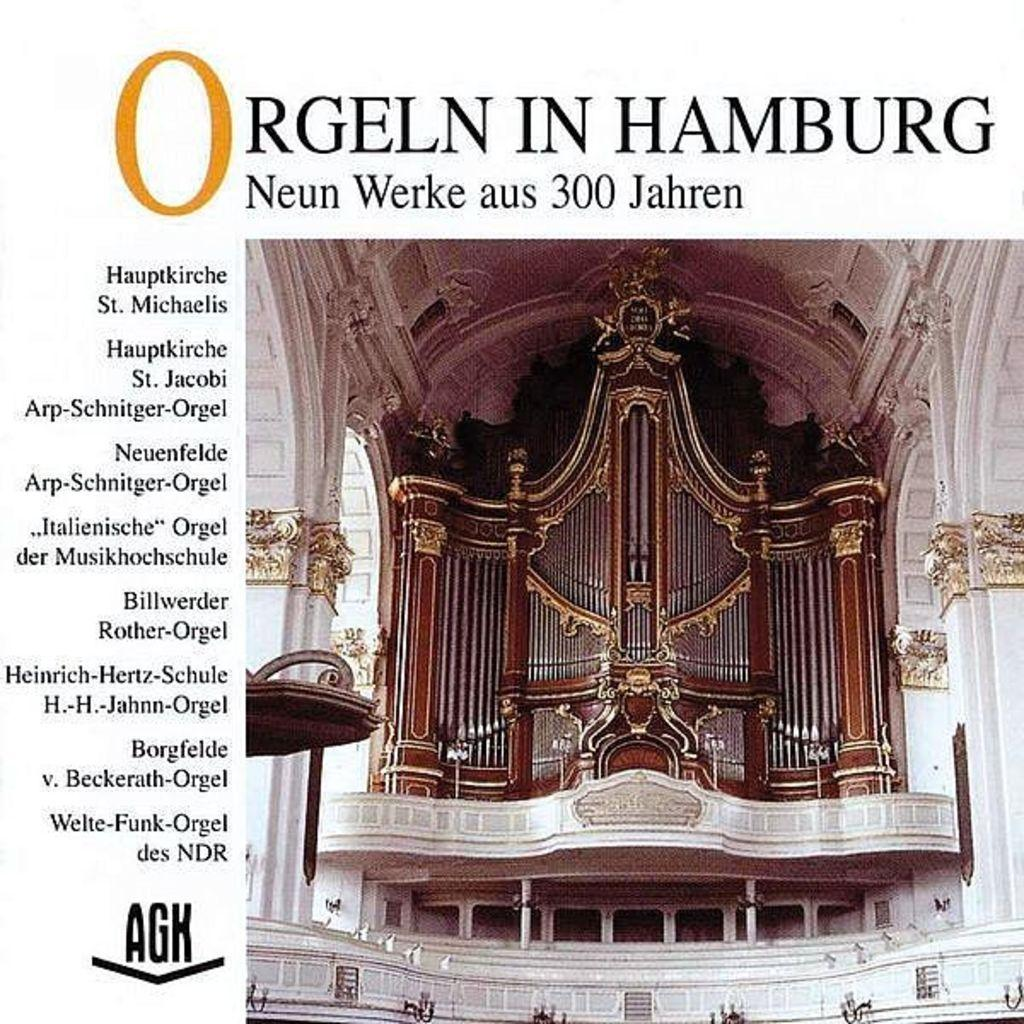What is the main subject of the image? The main subject of the image is a picture of a building. What architectural feature can be seen on the building? The building has pillars. Is there any text present on the building? Yes, there is text on the building. What type of shade is provided by the earth in the image? There is no earth or shade present in the image; it features a picture of a building with pillars and text. What kind of paste is being used to create the text on the building? There is no information about the type of paste used for the text on the building in the image. 